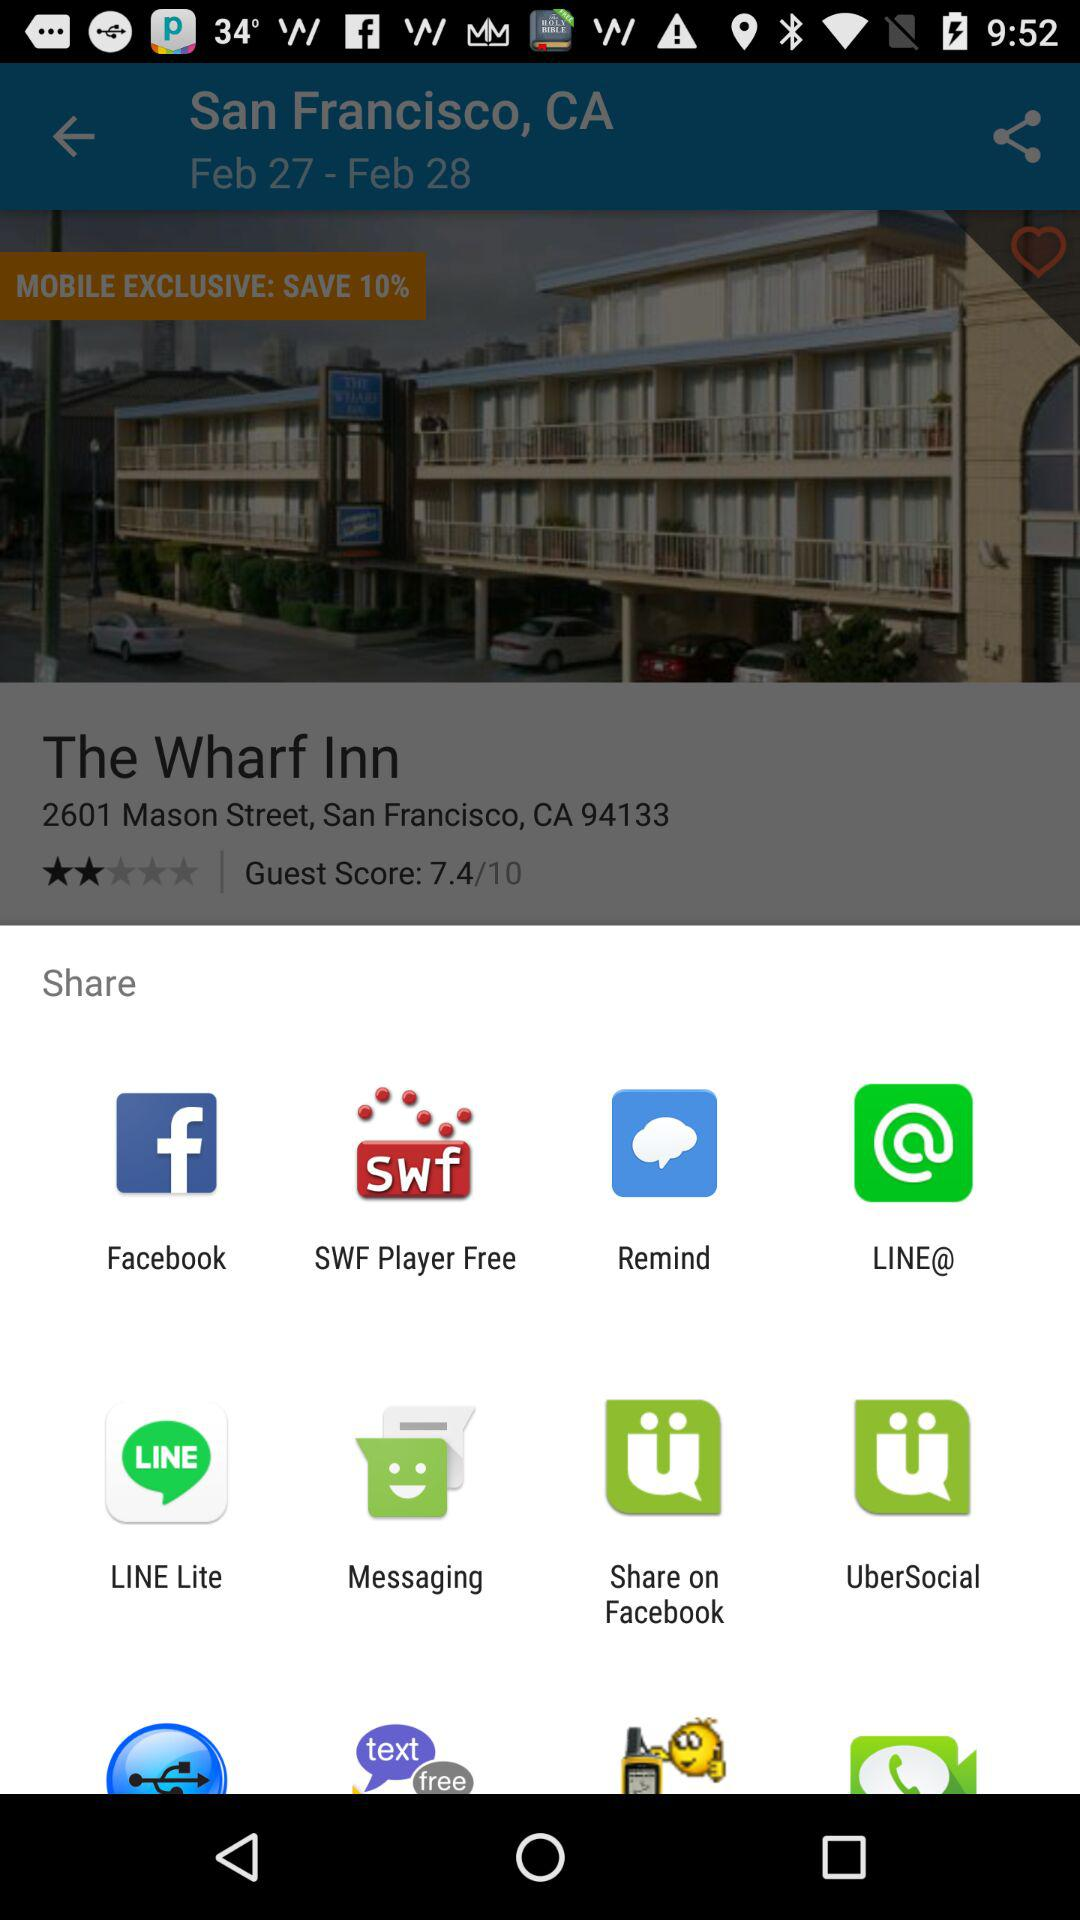Through which app can we share it? You can share it with: "Facebook", "SWF Player Free", "Remind", "LINE@", "LINE Lite", "Messaging", "Share on Facebook", and "UberSocial". 